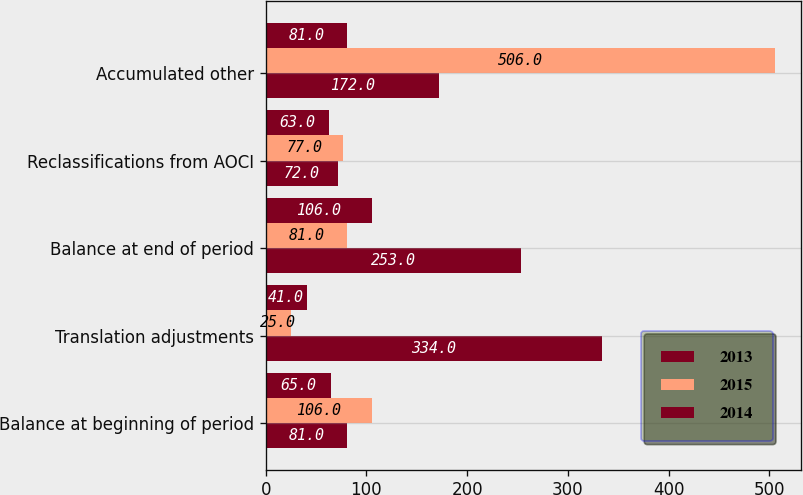Convert chart. <chart><loc_0><loc_0><loc_500><loc_500><stacked_bar_chart><ecel><fcel>Balance at beginning of period<fcel>Translation adjustments<fcel>Balance at end of period<fcel>Reclassifications from AOCI<fcel>Accumulated other<nl><fcel>2013<fcel>81<fcel>334<fcel>253<fcel>72<fcel>172<nl><fcel>2015<fcel>106<fcel>25<fcel>81<fcel>77<fcel>506<nl><fcel>2014<fcel>65<fcel>41<fcel>106<fcel>63<fcel>81<nl></chart> 